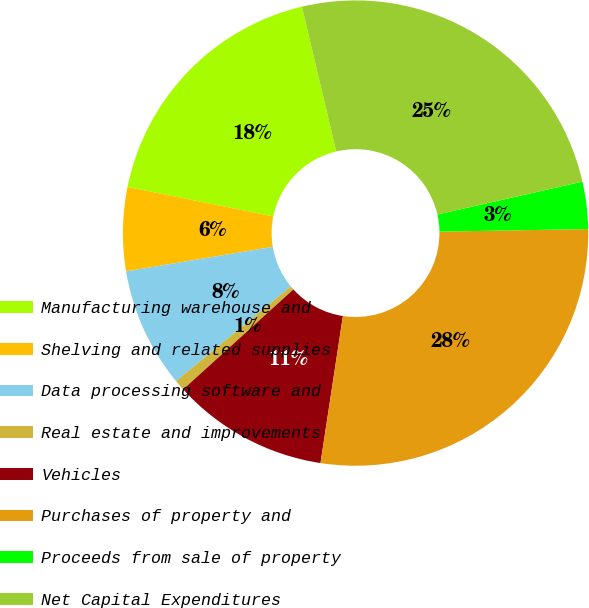<chart> <loc_0><loc_0><loc_500><loc_500><pie_chart><fcel>Manufacturing warehouse and<fcel>Shelving and related supplies<fcel>Data processing software and<fcel>Real estate and improvements<fcel>Vehicles<fcel>Purchases of property and<fcel>Proceeds from sale of property<fcel>Net Capital Expenditures<nl><fcel>18.12%<fcel>5.81%<fcel>8.34%<fcel>0.75%<fcel>10.87%<fcel>27.68%<fcel>3.28%<fcel>25.15%<nl></chart> 